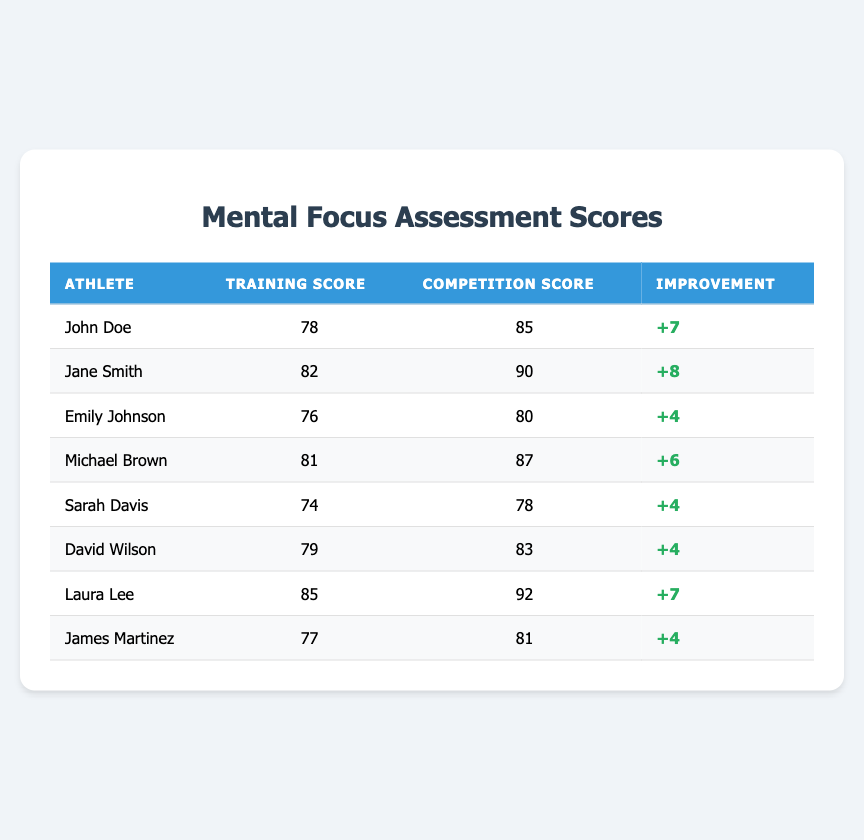What is the highest training score in the table? By examining the "Training Score" column, we find that Laura Lee has the highest score of 85.
Answer: 85 How many athletes improved their mental focus scores during competition compared to training? To find this, we can look at each athlete's score difference (Competition Score minus Training Score). If the difference is positive, then the athlete improved. Counting those with a positive difference gives us six athletes: John Doe, Jane Smith, Michael Brown, Laura Lee, David Wilson, and Sarah Davis.
Answer: 6 What is the average competition score of all athletes? We sum the competition scores (85 + 90 + 80 + 87 + 78 + 83 + 92 + 81) = 696. There are 8 athletes, so we divide 696 by 8 to get an average of 87.
Answer: 87 Did Sarah Davis have a higher training score than Emily Johnson? By comparing the "Training Score" for both athletes, Sarah Davis has a score of 74 while Emily Johnson has a score of 76. Since 74 is less than 76, Sarah did not have a higher training score than Emily.
Answer: No What is the total improvement of the athlete with the highest competition score? The athlete with the highest competition score is Jane Smith, whose improvement is calculated as 90 (Competition Score) - 82 (Training Score) = 8. Therefore, the total improvement for Jane Smith is 8.
Answer: 8 Which athlete had the least improvement in their mental focus score? We can look at the "Improvement" column to find the least improvement. Both Emily Johnson, Sarah Davis, David Wilson, and James Martinez have an improvement of 4, which is the lowest.
Answer: Emily Johnson, Sarah Davis, David Wilson, and James Martinez What is the difference between the highest and lowest training scores? The highest training score is 85 (Laura Lee) and the lowest is 74 (Sarah Davis). Therefore, the difference is 85 - 74 = 11.
Answer: 11 Which athlete improved their score the most during competition? By checking the "Improvement" column, we see that Jane Smith improved by 8 points, which is the highest increase compared to others.
Answer: Jane Smith 